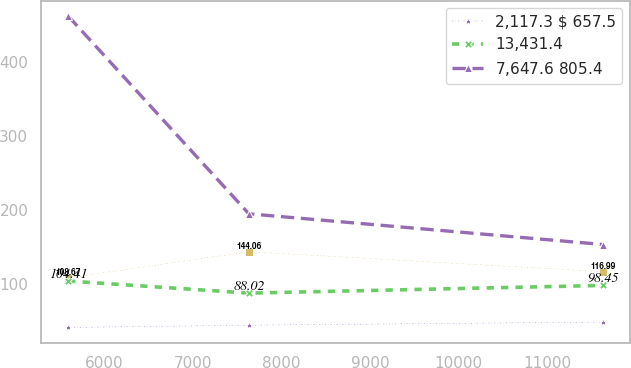Convert chart. <chart><loc_0><loc_0><loc_500><loc_500><line_chart><ecel><fcel>Unnamed: 1<fcel>2,117.3 $ 657.5<fcel>13,431.4<fcel>7,647.6 $ 805.4 $<nl><fcel>5591.81<fcel>108.67<fcel>41.59<fcel>104.41<fcel>462.76<nl><fcel>7630.77<fcel>144.06<fcel>44.64<fcel>88.02<fcel>195.3<nl><fcel>11628.8<fcel>116.99<fcel>48.92<fcel>98.45<fcel>153.74<nl></chart> 